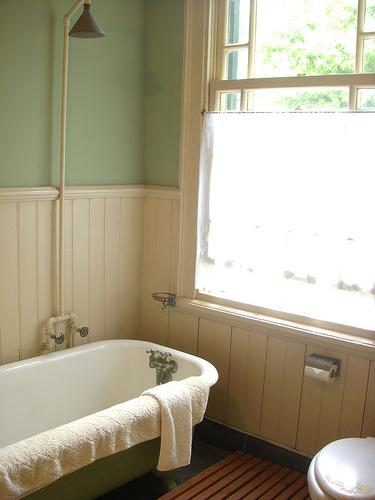What elements are found hanging from the edge of the bathtub? White bath towels and two other towels are draped over the side of the tub. What type of shower head is present in the image? There is a rainfall-type shower head in the image. How could you describe the overall design and condition of this bathroom? The bathroom is well-designed and clean, featuring a combination of modern and old-fashioned elements. Describe the different types of faucets and knobs in the bathroom. There are silver old bath tub faucets, two handles of hot and cold water, and shower knobs connected to a pipe. Explain the function of the two grey wrenches in the image. The two grey wrenches are probably used for adjusting or fixing the plumbing fixtures in the bathroom. What type of object is on the floor of the bathroom?  A brown wooden bath mat or a wood pallet is on the bathroom floor. In the image, where is the toilet paper located? The toilet paper is on the toilet roll holder, which is mounted on a wall. What kind of walls can be seen in this bathroom image? Sage green walls and light paneling are visible in the bathroom. Mention the key components of the bathroom and their colors. The bathroom contains a white and olive green bathtub, a white toilet, light green walls, and a big white window. Describe the things outside the window in the image. Green leaves and a tree can be seen outside the bright window. Can you identify the type and color of the faucets in the image? Silver old bath tub faucets. Describe the location and color of the toilet paper and holder. The toilet paper holder is on the wall, and it contains a roll of white toilet paper. Could you please point to the three blue wrenches in the image? There are only two grey wrenches in the image, not three blue wrenches. Which of the following objects can be seen in the image? A) white and olive green bath tub B) red couch C) wooden dining table A) white and olive green bath tub Can you identify the handle types of the faucets on the wall? Two handles of hot and cold water. Describe the scene outside the window in the image. There are green leaves and a tree outside the bright window. Can you locate the small black cat sitting on the toilet? There is no mention of a cat in any of the given objects, let alone a small black cat sitting on the toilet. Can you find the bright red bathtub in the image? There is no bright red bathtub in the image. The bathtub is described as white and olive green or old-fashioned green. Describe the type of toilet featured in the image. White toilet and seat, with the seat cover closed, next to a paneled wall. What color is the bath mat in the bathroom? Brown. What type of pipe can be seen in the image? Large white pipeline. What is the color and location of the bath towels? White bath towels in the tub and hanging from the edge of the bathtub. Is the toilet seat cover open or closed in this image? Toilet seat cover is closed. Could you find the orange rug next to the bathtub? There is a brown bath mat mentioned, but not an orange rug next to the bathtub. What type of shower head is mounted in the bathroom? Rainfall-type of showerhead Write a sentence that describes the emotional and aesthetic qualities of this bathroom. The bathroom has a well-designed and clean appearance, with sage green walls and light paneling. Describe the position and color of the soap dish in the image. The soap dish is mounted on the wall and has a pink soap in it. What are the two objects inside the tub that can be seen in the picture? Grey wrench and white bath towels. Where is the large purple elephant in the room? There is no mention of a purple elephant in any of the given objects present in the image. What is the color of the bathroom walls? Light green. What are the two types of objects hanging from the edge of the bathtub? White bath towels and a white towel. Identify the objects placed on the floor in the image. Brown bath mat and wood pallet. What is seen outside the large bathroom window? Bright sunshine shining through, green leaves, and a tree. Can you point to the pink and blue polka-dotted shower curtain hanging in the bathroom? There is no mention of a shower curtain in any of the given objects, let alone a pink and blue polka-dotted one. Describe the position and appearance of the shower head and knobs. Shower head with green wall behind it, shower knobs connected to pipe, and shadow of the shower head. 